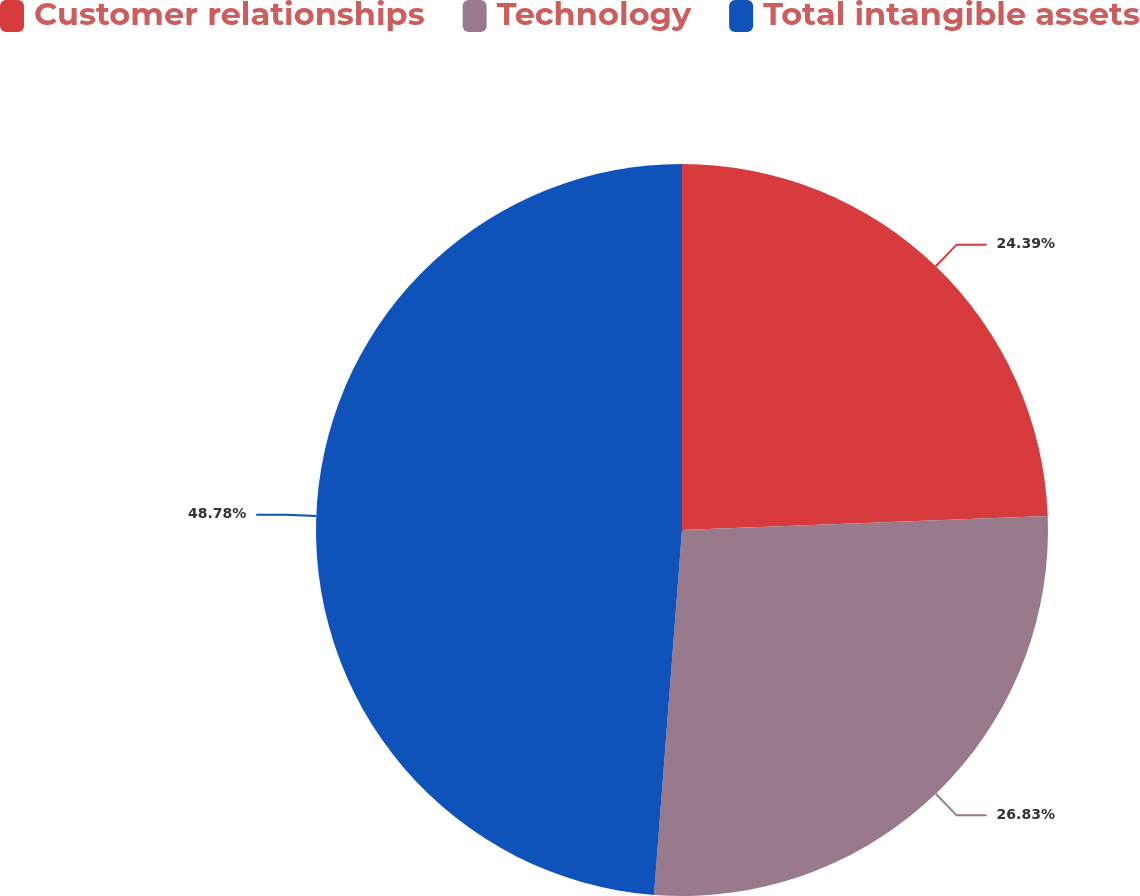Convert chart to OTSL. <chart><loc_0><loc_0><loc_500><loc_500><pie_chart><fcel>Customer relationships<fcel>Technology<fcel>Total intangible assets<nl><fcel>24.39%<fcel>26.83%<fcel>48.78%<nl></chart> 